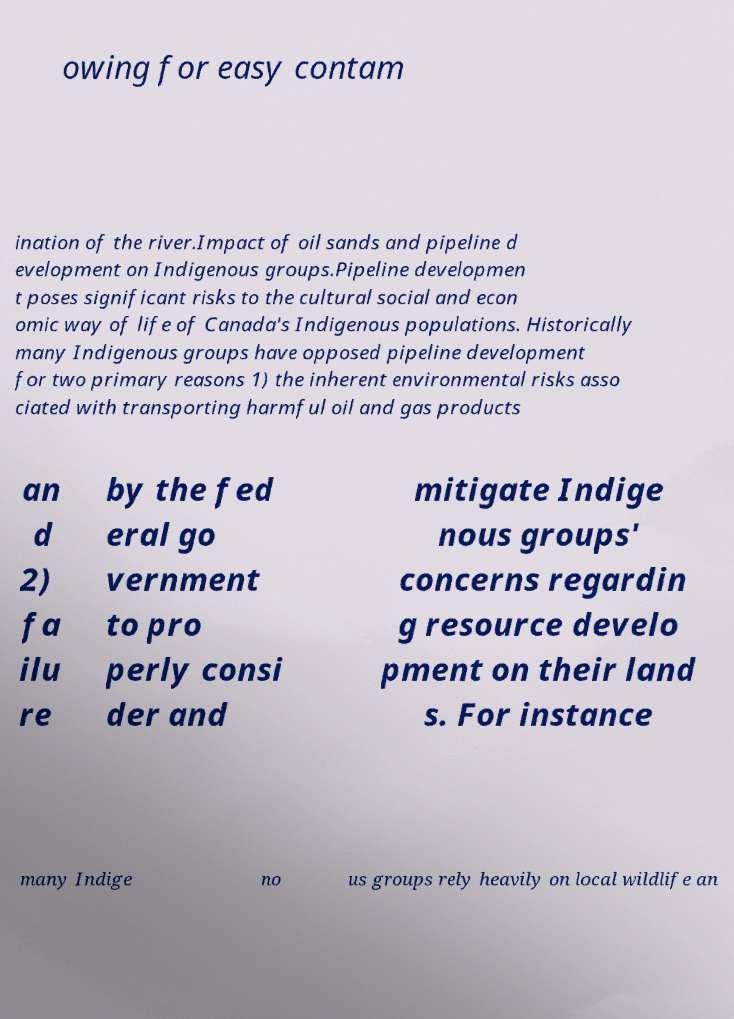What messages or text are displayed in this image? I need them in a readable, typed format. owing for easy contam ination of the river.Impact of oil sands and pipeline d evelopment on Indigenous groups.Pipeline developmen t poses significant risks to the cultural social and econ omic way of life of Canada's Indigenous populations. Historically many Indigenous groups have opposed pipeline development for two primary reasons 1) the inherent environmental risks asso ciated with transporting harmful oil and gas products an d 2) fa ilu re by the fed eral go vernment to pro perly consi der and mitigate Indige nous groups' concerns regardin g resource develo pment on their land s. For instance many Indige no us groups rely heavily on local wildlife an 